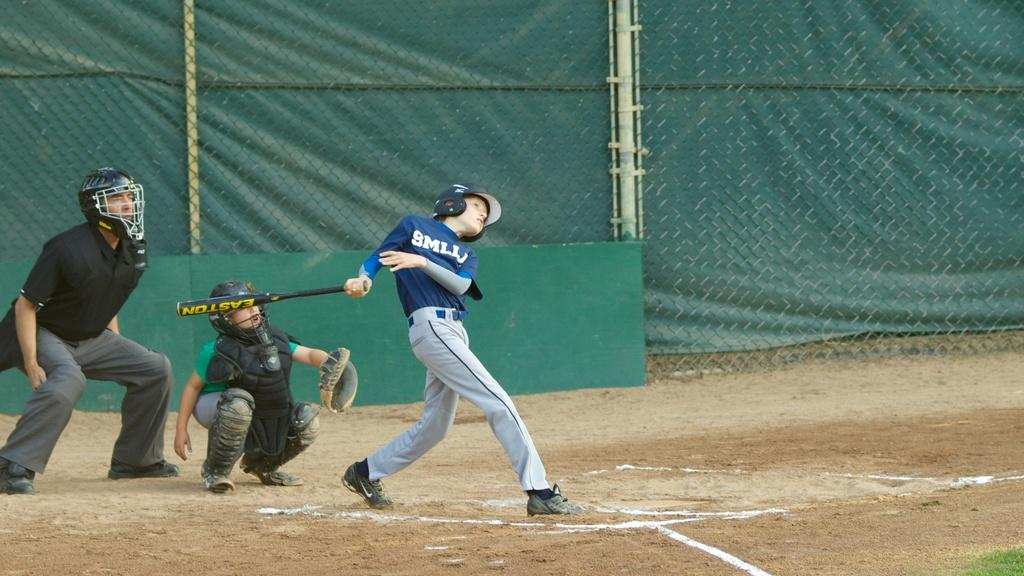<image>
Write a terse but informative summary of the picture. A boy playing baseball has "SMLL" on his shirt. 